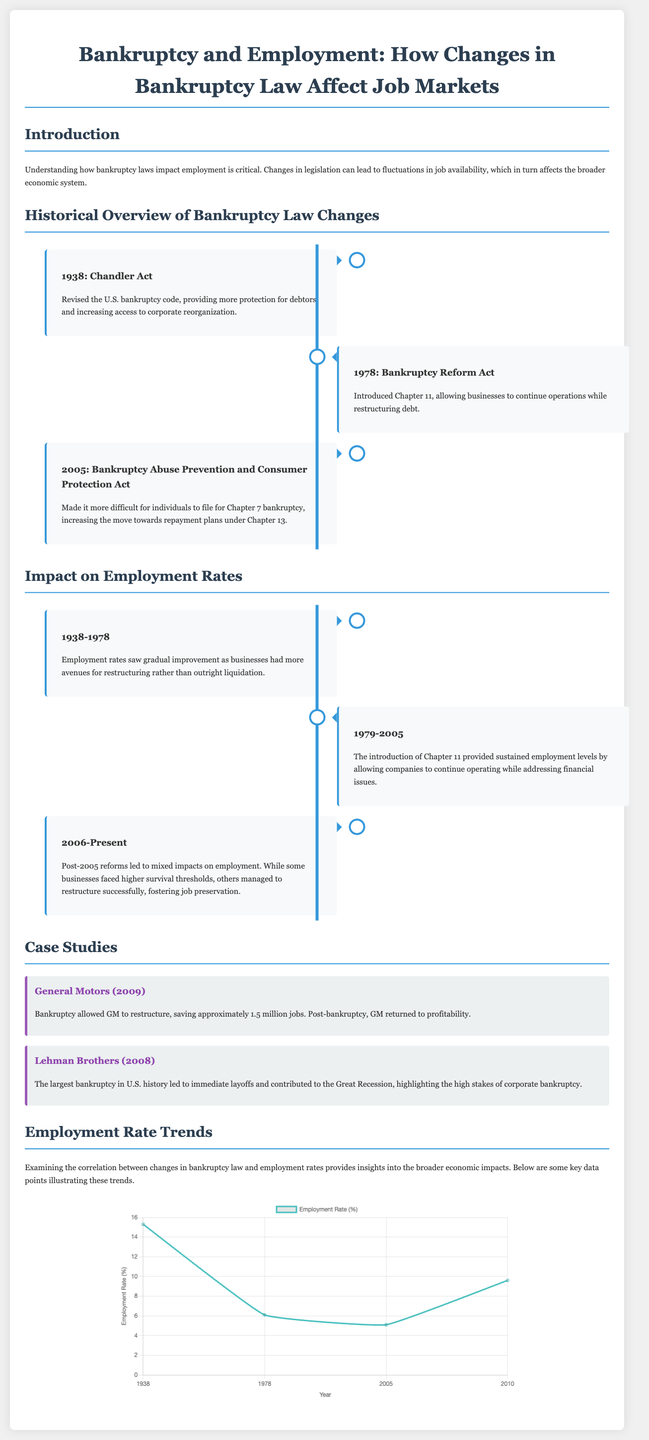What year was the Chandler Act introduced? The Chandler Act was introduced in 1938, as noted in the historical overview of bankruptcy law changes.
Answer: 1938 What major bankruptcy law was enacted in 2005? The significant bankruptcy law introduced in 2005 is the Bankruptcy Abuse Prevention and Consumer Protection Act.
Answer: Bankruptcy Abuse Prevention and Consumer Protection Act What was the employment rate in 1978? The employment rate in 1978, as shown in the employment rate trends chart, was 6.1%.
Answer: 6.1% Which case study highlighted a positive outcome of bankruptcy? The case study of General Motors in 2009 highlighted a positive outcome, saving approximately 1.5 million jobs.
Answer: General Motors What was the employment rate in 2010? The employment rate in 2010, according to the employment chart, was 9.6%.
Answer: 9.6% What type of bankruptcy did the Bankruptcy Reform Act introduce? The Bankruptcy Reform Act introduced Chapter 11 bankruptcy, allowing businesses to restructure while continuing operations.
Answer: Chapter 11 What event did the timeline correlate with a decline in employment rates post-2005? The timeline correlates the decline in employment rates post-2005 with the aftermath of the Great Recession.
Answer: Great Recession In what year did Lehman Brothers file for bankruptcy? Lehman Brothers filed for bankruptcy in 2008, which is mentioned in the case studies.
Answer: 2008 